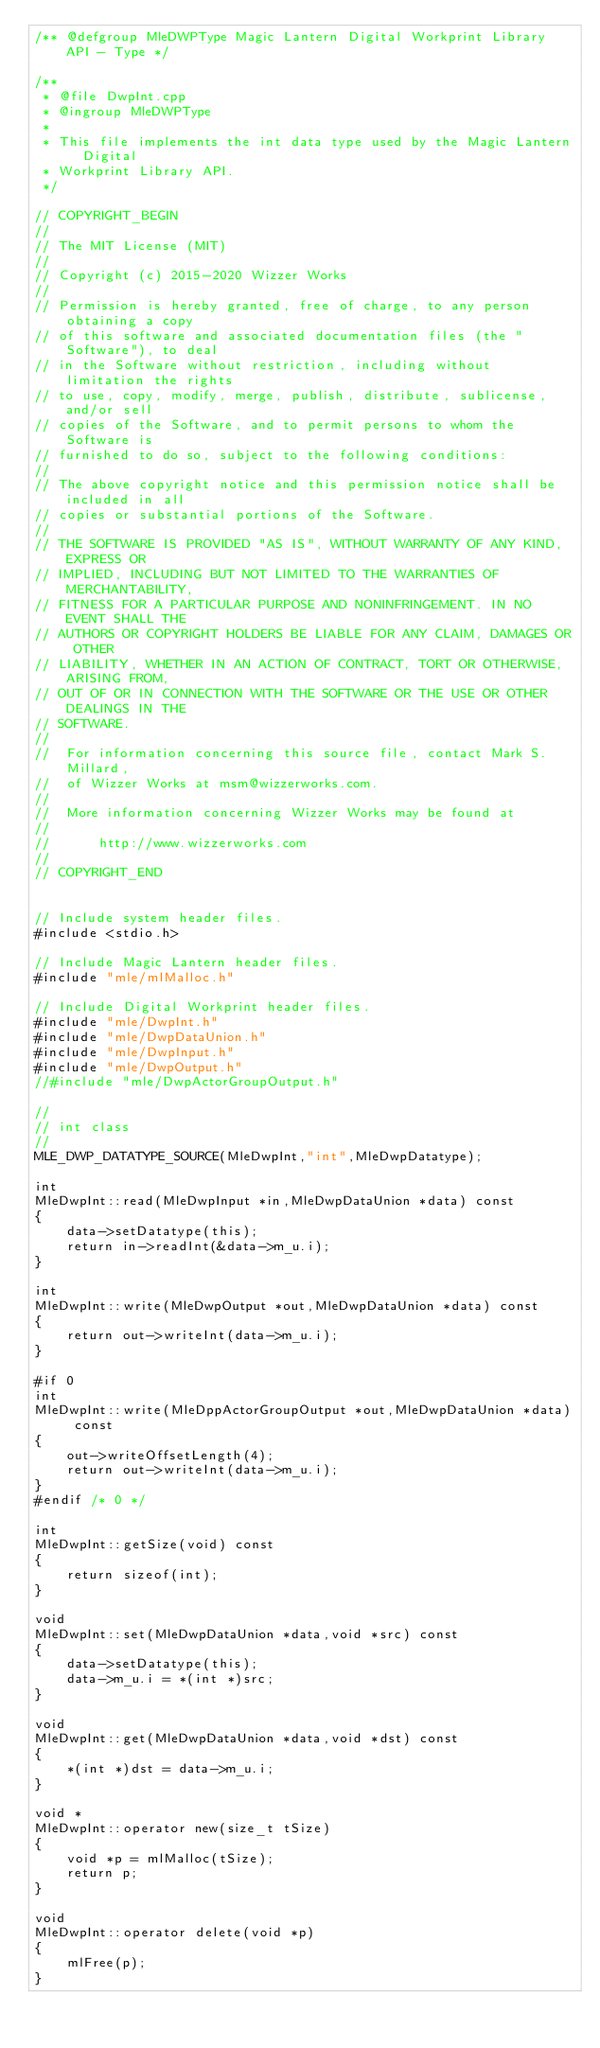Convert code to text. <code><loc_0><loc_0><loc_500><loc_500><_C++_>/** @defgroup MleDWPType Magic Lantern Digital Workprint Library API - Type */

/**
 * @file DwpInt.cpp
 * @ingroup MleDWPType
 *
 * This file implements the int data type used by the Magic Lantern Digital
 * Workprint Library API.
 */

// COPYRIGHT_BEGIN
//
// The MIT License (MIT)
//
// Copyright (c) 2015-2020 Wizzer Works
//
// Permission is hereby granted, free of charge, to any person obtaining a copy
// of this software and associated documentation files (the "Software"), to deal
// in the Software without restriction, including without limitation the rights
// to use, copy, modify, merge, publish, distribute, sublicense, and/or sell
// copies of the Software, and to permit persons to whom the Software is
// furnished to do so, subject to the following conditions:
//
// The above copyright notice and this permission notice shall be included in all
// copies or substantial portions of the Software.
//
// THE SOFTWARE IS PROVIDED "AS IS", WITHOUT WARRANTY OF ANY KIND, EXPRESS OR
// IMPLIED, INCLUDING BUT NOT LIMITED TO THE WARRANTIES OF MERCHANTABILITY,
// FITNESS FOR A PARTICULAR PURPOSE AND NONINFRINGEMENT. IN NO EVENT SHALL THE
// AUTHORS OR COPYRIGHT HOLDERS BE LIABLE FOR ANY CLAIM, DAMAGES OR OTHER
// LIABILITY, WHETHER IN AN ACTION OF CONTRACT, TORT OR OTHERWISE, ARISING FROM,
// OUT OF OR IN CONNECTION WITH THE SOFTWARE OR THE USE OR OTHER DEALINGS IN THE
// SOFTWARE.
//
//  For information concerning this source file, contact Mark S. Millard,
//  of Wizzer Works at msm@wizzerworks.com.
//
//  More information concerning Wizzer Works may be found at
//
//      http://www.wizzerworks.com
//
// COPYRIGHT_END


// Include system header files.
#include <stdio.h>

// Include Magic Lantern header files.
#include "mle/mlMalloc.h"

// Include Digital Workprint header files.
#include "mle/DwpInt.h"
#include "mle/DwpDataUnion.h"
#include "mle/DwpInput.h"
#include "mle/DwpOutput.h"
//#include "mle/DwpActorGroupOutput.h"

//
// int class
//
MLE_DWP_DATATYPE_SOURCE(MleDwpInt,"int",MleDwpDatatype);

int
MleDwpInt::read(MleDwpInput *in,MleDwpDataUnion *data) const
{
	data->setDatatype(this);
	return in->readInt(&data->m_u.i);
}

int
MleDwpInt::write(MleDwpOutput *out,MleDwpDataUnion *data) const
{
	return out->writeInt(data->m_u.i);
}

#if 0
int
MleDwpInt::write(MleDppActorGroupOutput *out,MleDwpDataUnion *data) const
{
	out->writeOffsetLength(4);
	return out->writeInt(data->m_u.i);
}
#endif /* 0 */

int
MleDwpInt::getSize(void) const
{
	return sizeof(int);
}

void
MleDwpInt::set(MleDwpDataUnion *data,void *src) const
{
	data->setDatatype(this);
	data->m_u.i = *(int *)src;
}

void
MleDwpInt::get(MleDwpDataUnion *data,void *dst) const
{
	*(int *)dst = data->m_u.i;
}

void *
MleDwpInt::operator new(size_t tSize)
{
	void *p = mlMalloc(tSize);
	return p;
}

void
MleDwpInt::operator delete(void *p)
{
	mlFree(p);
}
</code> 